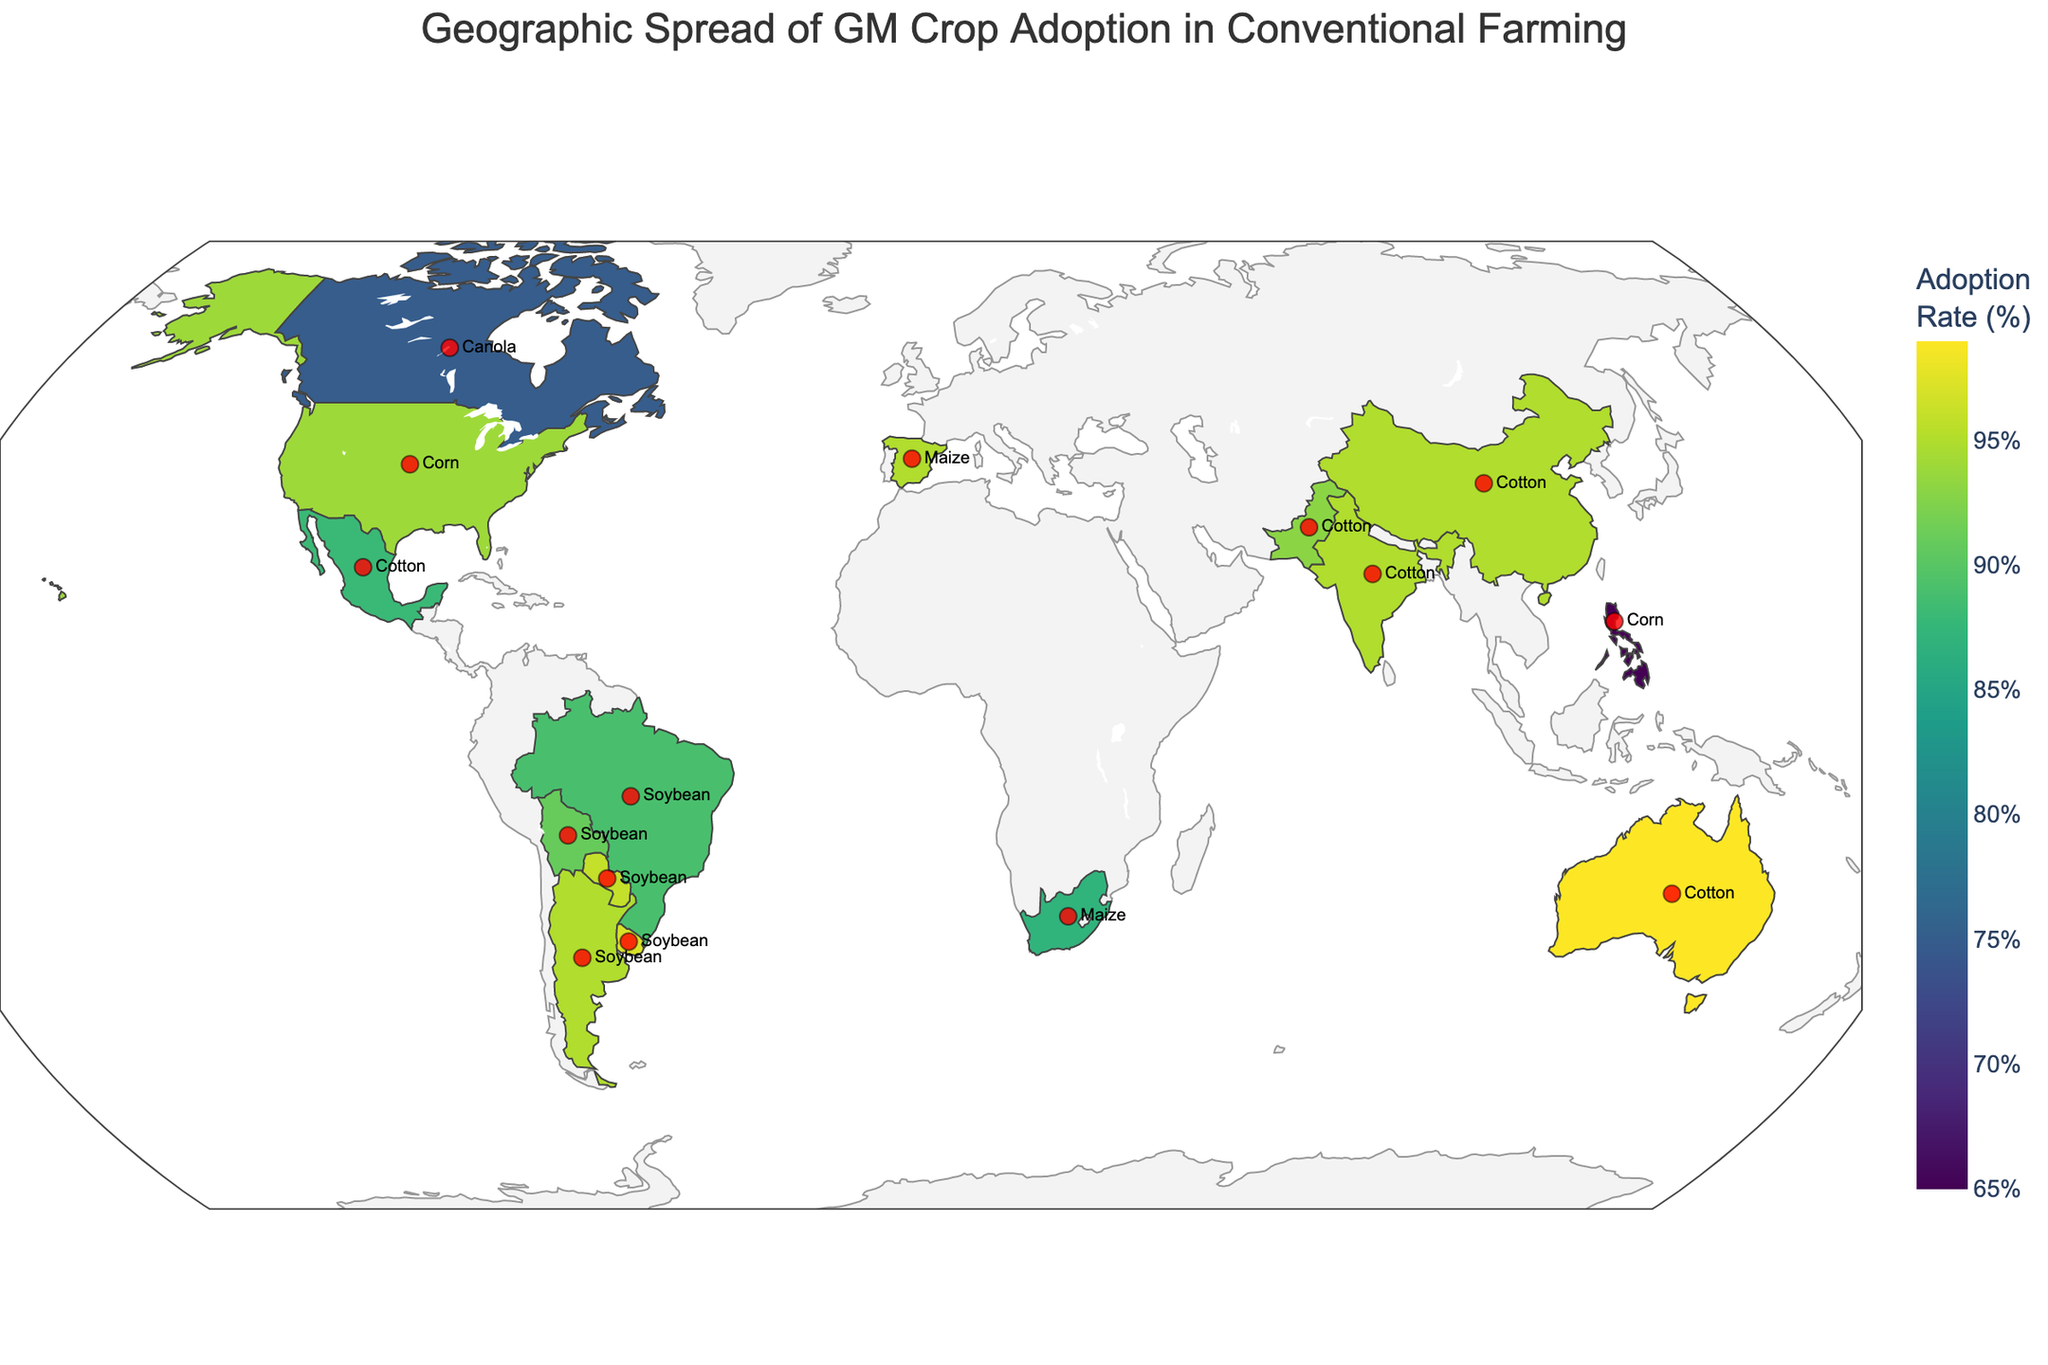What's the title of the plot? The title of the plot is displayed at the top and indicates the main subject of the visualization. It is "Geographic Spread of GM Crop Adoption in Conventional Farming."
Answer: Geographic Spread of GM Crop Adoption in Conventional Farming Which country has the highest adoption rate of GM crops? To find the country with the highest adoption rate, look at the color intensity on the map or the data points. Australia is shown with the highest adoption rate at 99%.
Answer: Australia What is the primary GM crop adopted in Brazil? By hovering over Brazil on the map or referencing the hover data, we can see that the primary GM crop is Soybean.
Answer: Soybean Compare the GM crops adopted in the United States and Philippines. The hover information reveals that the primary GM crop in the United States is Corn, while in the Philippines, it is also Corn.
Answer: Both adopt Corn How many countries have an adoption rate of 95% or more? By analyzing the data and the plot, we see Argentina, India, China, Paraguay, Uruguay, Spain, and Australia have adoption rates of 95% or more, totaling 7 countries.
Answer: 7 Which country shows the lowest adoption rate, and what is it? By examining the color legend, the Philippines has the lowest adoption rate at 65%.
Answer: Philippines, 65% What's the average adoption rate of GM crops across all countries listed? First, sum the adoption rates from the data: 94+89+95+75+95+95+87+96+93+91+97+99+65+88+95 = 1259. Divide by the number of countries, 15. The average is 1259/15 = 83.93%.
Answer: 83.93% Which countries adopt Cotton as their primary GM crop? By inspecting the hover data, the countries adopting Cotton as their primary GM crop are India, China, Pakistan, Mexico, and Australia.
Answer: India, China, Pakistan, Mexico, Australia How does the adoption rate of GM crops in South Africa compare to that in Bolivia? The hover data shows South Africa's adoption rate is 87%, while Bolivia's is 91%. Bolivia has a higher adoption rate than South Africa.
Answer: Bolivia's rate is higher Which three countries have the highest adoption rates and what are they? By observing the darkest shades and consulting hover data, Uruguay (97%), Australia (99%), and Paraguay (96%) have the highest adoption rates.
Answer: Australia (99%), Uruguay (97%), Paraguay (96%) 